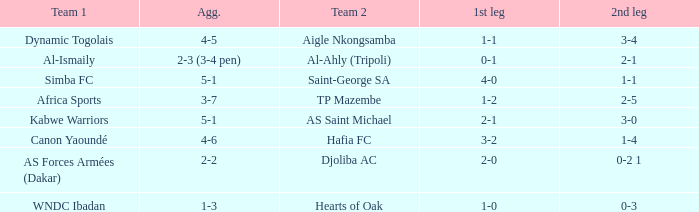What was the score of the second leg in the match that had a 2-0 result in the first leg? 0-2 1. 